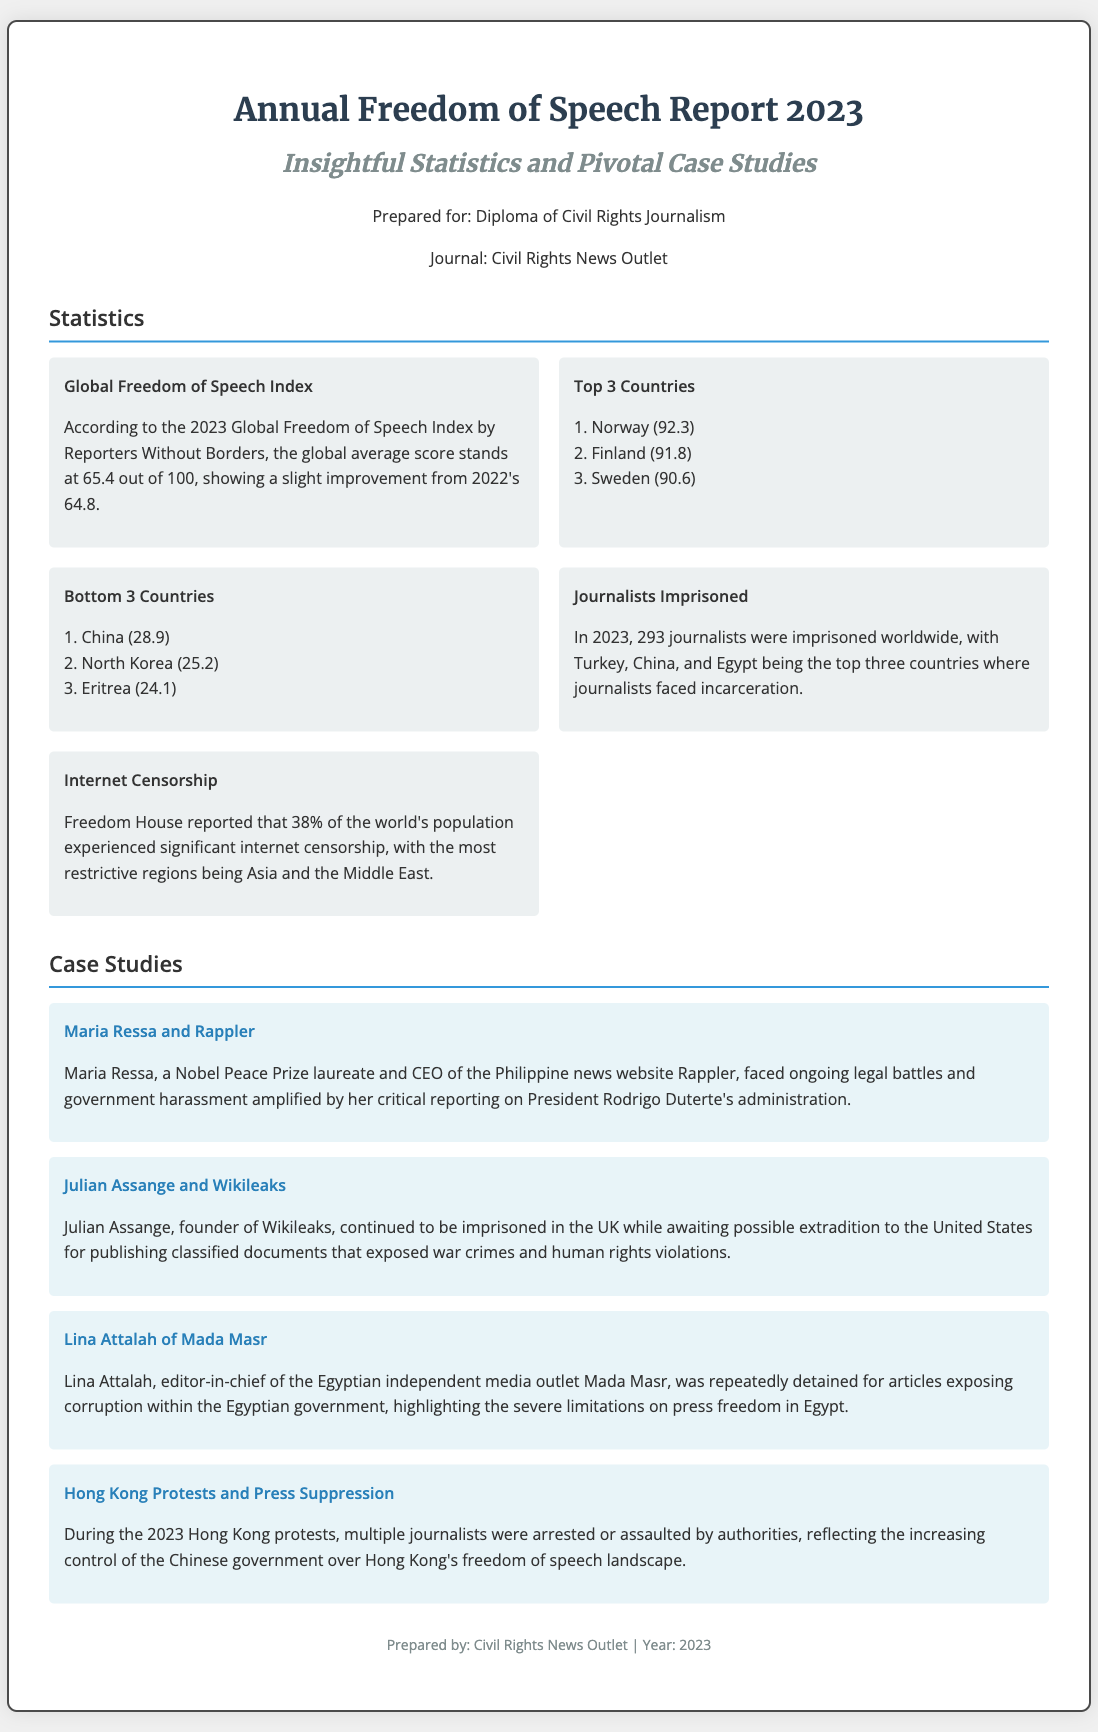What is the global average score on the Freedom of Speech Index? The global average score on the Freedom of Speech Index according to the document is specified as 65.4 out of 100.
Answer: 65.4 Who is the CEO of Rappler? The document mentions Maria Ressa as the CEO of Rappler, which highlights her importance in the context of freedom of speech.
Answer: Maria Ressa What are the bottom three countries for freedom of speech? The bottom three countries listed in the document are China, North Korea, and Eritrea, showing the most critical situations regarding freedom of expression.
Answer: China, North Korea, Eritrea How many journalists were imprisoned worldwide in 2023? The document states that 293 journalists were imprisoned worldwide in 2023, underlining the severity of the situation.
Answer: 293 What percentage of the world's population experienced significant internet censorship? The document indicates that 38% of the world's population experienced significant internet censorship, highlighting the extensive reach of restrictions.
Answer: 38% What case study involves a Nobel Peace Prize laureate? The document refers to Maria Ressa's case as involving a Nobel Peace Prize laureate, demonstrating her significance in the media landscape.
Answer: Maria Ressa Which country had the highest score on the Freedom of Speech Index? According to the document, Norway topped the list with the highest score of 92.3 on the Freedom of Speech Index.
Answer: Norway What governmental action was taken against Lina Attalah? The document describes that Lina Attalah was repeatedly detained for her critical reporting, reflecting press freedom limitations in Egypt.
Answer: Repeatedly detained What event involved arrests or assaults on journalists in 2023? The document describes the Hong Kong protests as an event where multiple journalists faced arrests or assaults, indicating an aggressive stance on media freedom.
Answer: Hong Kong protests 